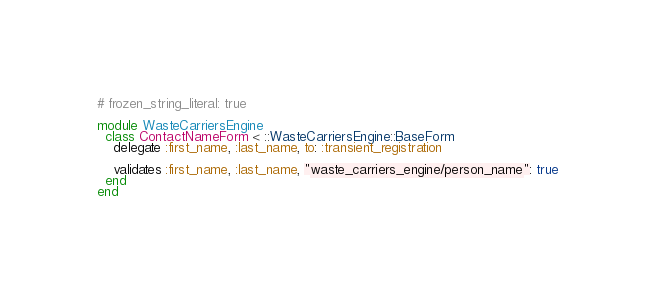<code> <loc_0><loc_0><loc_500><loc_500><_Ruby_># frozen_string_literal: true

module WasteCarriersEngine
  class ContactNameForm < ::WasteCarriersEngine::BaseForm
    delegate :first_name, :last_name, to: :transient_registration

    validates :first_name, :last_name, "waste_carriers_engine/person_name": true
  end
end
</code> 